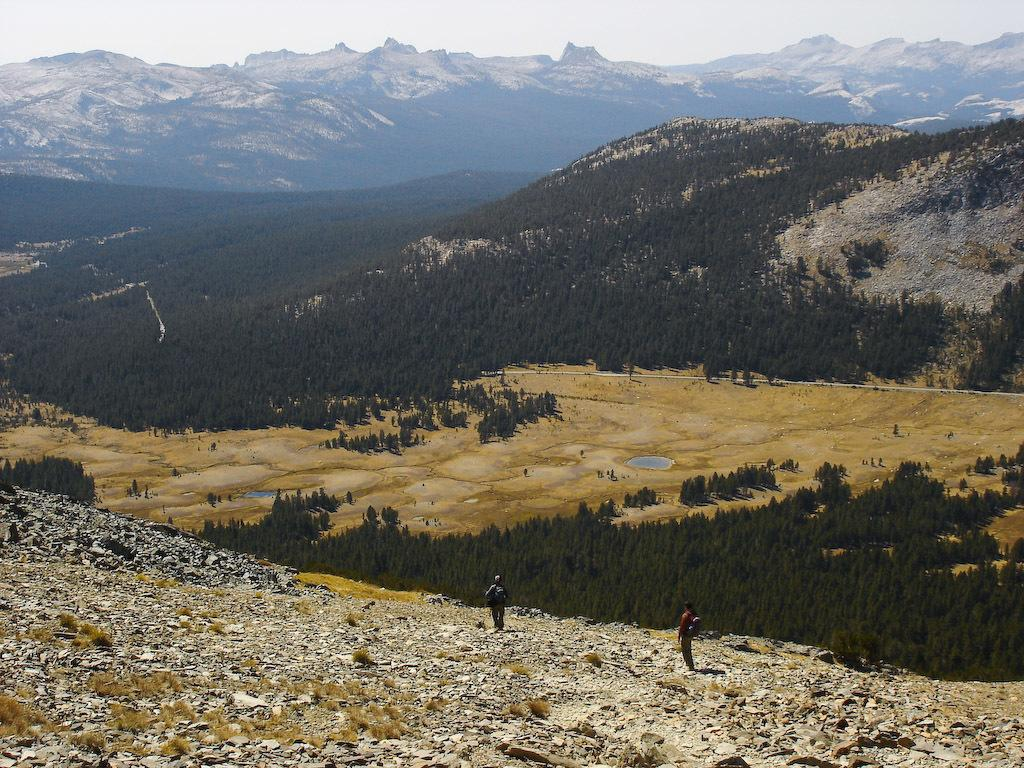How many people are present in the image? There are two people on the ground in the image. What can be seen in the background of the image? There are many trees and mountains visible in the background of the image. What is visible in the sky in the image? The sky is visible in the background of the image. What type of chin can be seen on the corn in the image? There is no corn present in the image, and therefore no chin can be seen on it. What type of plough is being used by the people in the image? There is no plough visible in the image; the two people are not engaged in any farming activity. 